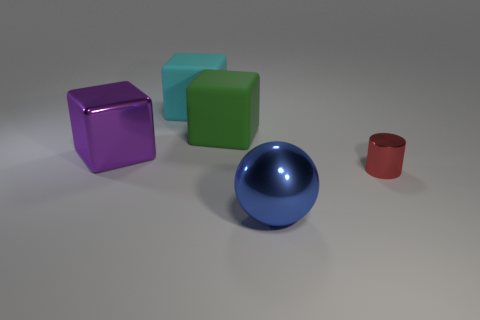Add 1 big cyan rubber cubes. How many objects exist? 6 Subtract all cylinders. How many objects are left? 4 Add 4 red rubber spheres. How many red rubber spheres exist? 4 Subtract 0 brown blocks. How many objects are left? 5 Subtract all gray rubber things. Subtract all metallic cylinders. How many objects are left? 4 Add 5 red things. How many red things are left? 6 